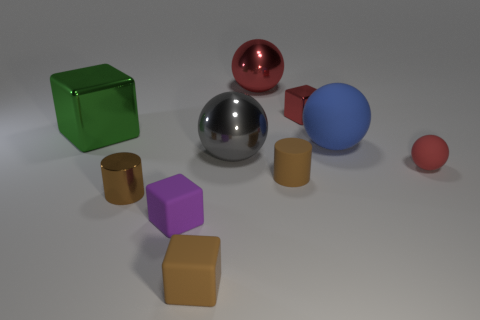Subtract all purple cubes. How many cubes are left? 3 Subtract all red spheres. How many spheres are left? 2 Subtract all spheres. How many objects are left? 6 Subtract 3 blocks. How many blocks are left? 1 Add 4 big rubber things. How many big rubber things are left? 5 Add 4 blue objects. How many blue objects exist? 5 Subtract 0 brown spheres. How many objects are left? 10 Subtract all green spheres. Subtract all yellow cubes. How many spheres are left? 4 Subtract all brown balls. How many green cubes are left? 1 Subtract all small cyan metal cylinders. Subtract all large shiny blocks. How many objects are left? 9 